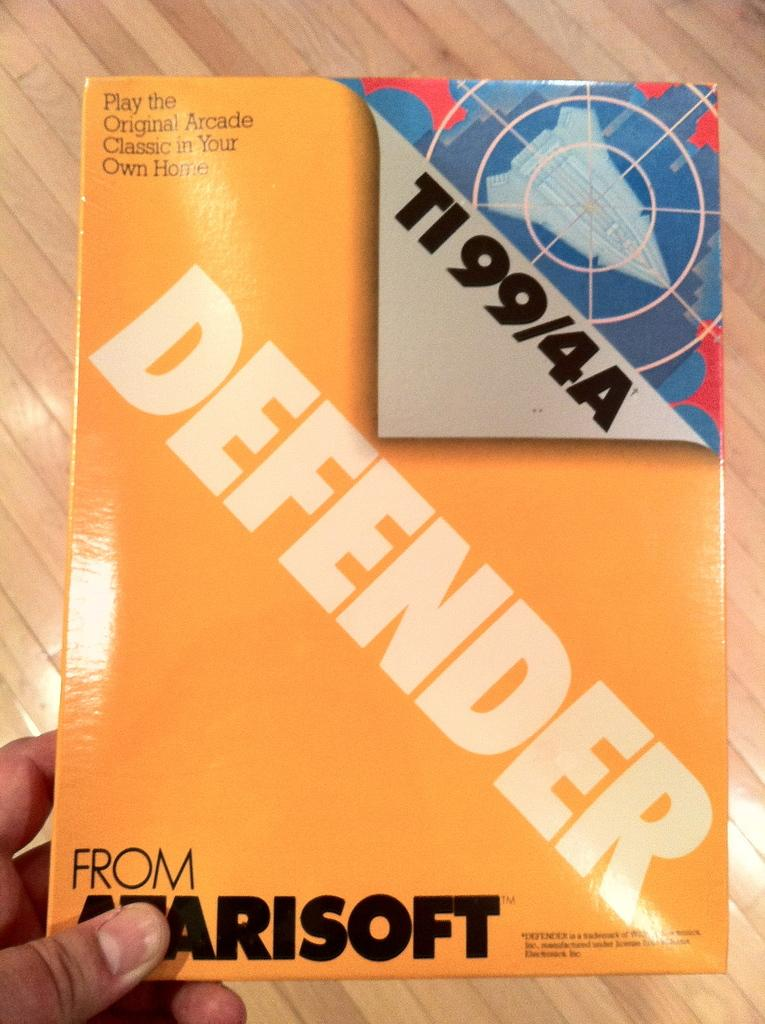<image>
Present a compact description of the photo's key features. A yellow paper that reads Defender from Marisoft 